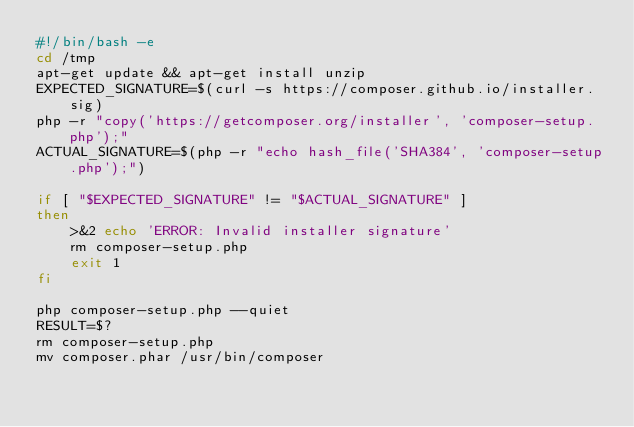<code> <loc_0><loc_0><loc_500><loc_500><_Bash_>#!/bin/bash -e
cd /tmp
apt-get update && apt-get install unzip
EXPECTED_SIGNATURE=$(curl -s https://composer.github.io/installer.sig)
php -r "copy('https://getcomposer.org/installer', 'composer-setup.php');"
ACTUAL_SIGNATURE=$(php -r "echo hash_file('SHA384', 'composer-setup.php');")

if [ "$EXPECTED_SIGNATURE" != "$ACTUAL_SIGNATURE" ]
then
    >&2 echo 'ERROR: Invalid installer signature'
    rm composer-setup.php
    exit 1
fi

php composer-setup.php --quiet
RESULT=$?
rm composer-setup.php
mv composer.phar /usr/bin/composer
</code> 